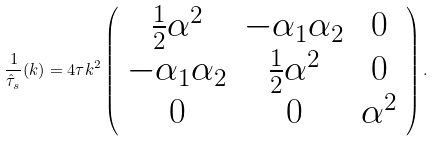<formula> <loc_0><loc_0><loc_500><loc_500>\frac { 1 } { \hat { \tau } _ { s } } ( k ) = 4 \tau k ^ { 2 } \left ( \begin{array} { c c c } \frac { 1 } { 2 } \alpha ^ { 2 } & - \alpha _ { 1 } \alpha _ { 2 } & 0 \\ - \alpha _ { 1 } \alpha _ { 2 } & \frac { 1 } { 2 } \alpha ^ { 2 } & 0 \\ 0 & 0 & \alpha ^ { 2 } \end{array} \right ) .</formula> 